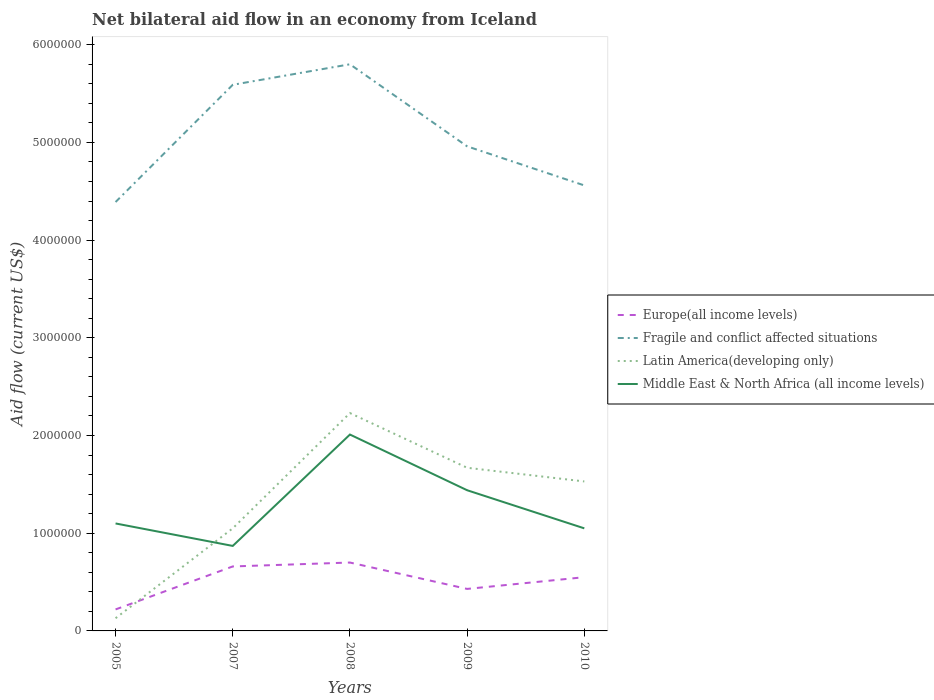What is the total net bilateral aid flow in Fragile and conflict affected situations in the graph?
Make the answer very short. 4.00e+05. What is the difference between the highest and the lowest net bilateral aid flow in Latin America(developing only)?
Ensure brevity in your answer.  3. Is the net bilateral aid flow in Fragile and conflict affected situations strictly greater than the net bilateral aid flow in Europe(all income levels) over the years?
Your answer should be compact. No. How many years are there in the graph?
Provide a succinct answer. 5. What is the difference between two consecutive major ticks on the Y-axis?
Provide a short and direct response. 1.00e+06. Are the values on the major ticks of Y-axis written in scientific E-notation?
Keep it short and to the point. No. Does the graph contain any zero values?
Give a very brief answer. No. Does the graph contain grids?
Your response must be concise. No. Where does the legend appear in the graph?
Your answer should be very brief. Center right. What is the title of the graph?
Make the answer very short. Net bilateral aid flow in an economy from Iceland. What is the Aid flow (current US$) of Europe(all income levels) in 2005?
Offer a terse response. 2.20e+05. What is the Aid flow (current US$) of Fragile and conflict affected situations in 2005?
Keep it short and to the point. 4.39e+06. What is the Aid flow (current US$) in Middle East & North Africa (all income levels) in 2005?
Give a very brief answer. 1.10e+06. What is the Aid flow (current US$) in Fragile and conflict affected situations in 2007?
Offer a terse response. 5.59e+06. What is the Aid flow (current US$) of Latin America(developing only) in 2007?
Offer a terse response. 1.05e+06. What is the Aid flow (current US$) of Middle East & North Africa (all income levels) in 2007?
Keep it short and to the point. 8.70e+05. What is the Aid flow (current US$) in Europe(all income levels) in 2008?
Give a very brief answer. 7.00e+05. What is the Aid flow (current US$) in Fragile and conflict affected situations in 2008?
Make the answer very short. 5.80e+06. What is the Aid flow (current US$) of Latin America(developing only) in 2008?
Offer a very short reply. 2.23e+06. What is the Aid flow (current US$) in Middle East & North Africa (all income levels) in 2008?
Offer a terse response. 2.01e+06. What is the Aid flow (current US$) of Fragile and conflict affected situations in 2009?
Your answer should be compact. 4.96e+06. What is the Aid flow (current US$) in Latin America(developing only) in 2009?
Your answer should be very brief. 1.67e+06. What is the Aid flow (current US$) of Middle East & North Africa (all income levels) in 2009?
Your response must be concise. 1.44e+06. What is the Aid flow (current US$) of Europe(all income levels) in 2010?
Ensure brevity in your answer.  5.50e+05. What is the Aid flow (current US$) in Fragile and conflict affected situations in 2010?
Offer a terse response. 4.56e+06. What is the Aid flow (current US$) in Latin America(developing only) in 2010?
Ensure brevity in your answer.  1.53e+06. What is the Aid flow (current US$) of Middle East & North Africa (all income levels) in 2010?
Provide a short and direct response. 1.05e+06. Across all years, what is the maximum Aid flow (current US$) of Europe(all income levels)?
Provide a short and direct response. 7.00e+05. Across all years, what is the maximum Aid flow (current US$) of Fragile and conflict affected situations?
Offer a terse response. 5.80e+06. Across all years, what is the maximum Aid flow (current US$) of Latin America(developing only)?
Ensure brevity in your answer.  2.23e+06. Across all years, what is the maximum Aid flow (current US$) in Middle East & North Africa (all income levels)?
Your answer should be compact. 2.01e+06. Across all years, what is the minimum Aid flow (current US$) of Fragile and conflict affected situations?
Provide a short and direct response. 4.39e+06. Across all years, what is the minimum Aid flow (current US$) in Latin America(developing only)?
Make the answer very short. 1.30e+05. Across all years, what is the minimum Aid flow (current US$) in Middle East & North Africa (all income levels)?
Your answer should be compact. 8.70e+05. What is the total Aid flow (current US$) in Europe(all income levels) in the graph?
Make the answer very short. 2.56e+06. What is the total Aid flow (current US$) of Fragile and conflict affected situations in the graph?
Your answer should be compact. 2.53e+07. What is the total Aid flow (current US$) in Latin America(developing only) in the graph?
Give a very brief answer. 6.61e+06. What is the total Aid flow (current US$) in Middle East & North Africa (all income levels) in the graph?
Offer a terse response. 6.47e+06. What is the difference between the Aid flow (current US$) in Europe(all income levels) in 2005 and that in 2007?
Offer a very short reply. -4.40e+05. What is the difference between the Aid flow (current US$) of Fragile and conflict affected situations in 2005 and that in 2007?
Your answer should be compact. -1.20e+06. What is the difference between the Aid flow (current US$) in Latin America(developing only) in 2005 and that in 2007?
Give a very brief answer. -9.20e+05. What is the difference between the Aid flow (current US$) of Middle East & North Africa (all income levels) in 2005 and that in 2007?
Offer a terse response. 2.30e+05. What is the difference between the Aid flow (current US$) of Europe(all income levels) in 2005 and that in 2008?
Your response must be concise. -4.80e+05. What is the difference between the Aid flow (current US$) in Fragile and conflict affected situations in 2005 and that in 2008?
Your response must be concise. -1.41e+06. What is the difference between the Aid flow (current US$) of Latin America(developing only) in 2005 and that in 2008?
Provide a short and direct response. -2.10e+06. What is the difference between the Aid flow (current US$) of Middle East & North Africa (all income levels) in 2005 and that in 2008?
Your response must be concise. -9.10e+05. What is the difference between the Aid flow (current US$) in Europe(all income levels) in 2005 and that in 2009?
Keep it short and to the point. -2.10e+05. What is the difference between the Aid flow (current US$) in Fragile and conflict affected situations in 2005 and that in 2009?
Make the answer very short. -5.70e+05. What is the difference between the Aid flow (current US$) in Latin America(developing only) in 2005 and that in 2009?
Your response must be concise. -1.54e+06. What is the difference between the Aid flow (current US$) of Middle East & North Africa (all income levels) in 2005 and that in 2009?
Offer a very short reply. -3.40e+05. What is the difference between the Aid flow (current US$) of Europe(all income levels) in 2005 and that in 2010?
Give a very brief answer. -3.30e+05. What is the difference between the Aid flow (current US$) of Fragile and conflict affected situations in 2005 and that in 2010?
Provide a succinct answer. -1.70e+05. What is the difference between the Aid flow (current US$) in Latin America(developing only) in 2005 and that in 2010?
Ensure brevity in your answer.  -1.40e+06. What is the difference between the Aid flow (current US$) of Fragile and conflict affected situations in 2007 and that in 2008?
Ensure brevity in your answer.  -2.10e+05. What is the difference between the Aid flow (current US$) in Latin America(developing only) in 2007 and that in 2008?
Your answer should be very brief. -1.18e+06. What is the difference between the Aid flow (current US$) in Middle East & North Africa (all income levels) in 2007 and that in 2008?
Your answer should be very brief. -1.14e+06. What is the difference between the Aid flow (current US$) of Fragile and conflict affected situations in 2007 and that in 2009?
Ensure brevity in your answer.  6.30e+05. What is the difference between the Aid flow (current US$) of Latin America(developing only) in 2007 and that in 2009?
Give a very brief answer. -6.20e+05. What is the difference between the Aid flow (current US$) in Middle East & North Africa (all income levels) in 2007 and that in 2009?
Provide a short and direct response. -5.70e+05. What is the difference between the Aid flow (current US$) of Fragile and conflict affected situations in 2007 and that in 2010?
Make the answer very short. 1.03e+06. What is the difference between the Aid flow (current US$) in Latin America(developing only) in 2007 and that in 2010?
Give a very brief answer. -4.80e+05. What is the difference between the Aid flow (current US$) in Europe(all income levels) in 2008 and that in 2009?
Ensure brevity in your answer.  2.70e+05. What is the difference between the Aid flow (current US$) in Fragile and conflict affected situations in 2008 and that in 2009?
Provide a succinct answer. 8.40e+05. What is the difference between the Aid flow (current US$) of Latin America(developing only) in 2008 and that in 2009?
Your answer should be compact. 5.60e+05. What is the difference between the Aid flow (current US$) in Middle East & North Africa (all income levels) in 2008 and that in 2009?
Provide a short and direct response. 5.70e+05. What is the difference between the Aid flow (current US$) of Europe(all income levels) in 2008 and that in 2010?
Provide a short and direct response. 1.50e+05. What is the difference between the Aid flow (current US$) of Fragile and conflict affected situations in 2008 and that in 2010?
Ensure brevity in your answer.  1.24e+06. What is the difference between the Aid flow (current US$) of Latin America(developing only) in 2008 and that in 2010?
Make the answer very short. 7.00e+05. What is the difference between the Aid flow (current US$) of Middle East & North Africa (all income levels) in 2008 and that in 2010?
Make the answer very short. 9.60e+05. What is the difference between the Aid flow (current US$) in Europe(all income levels) in 2009 and that in 2010?
Provide a succinct answer. -1.20e+05. What is the difference between the Aid flow (current US$) in Latin America(developing only) in 2009 and that in 2010?
Offer a terse response. 1.40e+05. What is the difference between the Aid flow (current US$) of Europe(all income levels) in 2005 and the Aid flow (current US$) of Fragile and conflict affected situations in 2007?
Your answer should be compact. -5.37e+06. What is the difference between the Aid flow (current US$) in Europe(all income levels) in 2005 and the Aid flow (current US$) in Latin America(developing only) in 2007?
Offer a terse response. -8.30e+05. What is the difference between the Aid flow (current US$) of Europe(all income levels) in 2005 and the Aid flow (current US$) of Middle East & North Africa (all income levels) in 2007?
Ensure brevity in your answer.  -6.50e+05. What is the difference between the Aid flow (current US$) in Fragile and conflict affected situations in 2005 and the Aid flow (current US$) in Latin America(developing only) in 2007?
Provide a succinct answer. 3.34e+06. What is the difference between the Aid flow (current US$) of Fragile and conflict affected situations in 2005 and the Aid flow (current US$) of Middle East & North Africa (all income levels) in 2007?
Make the answer very short. 3.52e+06. What is the difference between the Aid flow (current US$) in Latin America(developing only) in 2005 and the Aid flow (current US$) in Middle East & North Africa (all income levels) in 2007?
Provide a short and direct response. -7.40e+05. What is the difference between the Aid flow (current US$) in Europe(all income levels) in 2005 and the Aid flow (current US$) in Fragile and conflict affected situations in 2008?
Keep it short and to the point. -5.58e+06. What is the difference between the Aid flow (current US$) of Europe(all income levels) in 2005 and the Aid flow (current US$) of Latin America(developing only) in 2008?
Make the answer very short. -2.01e+06. What is the difference between the Aid flow (current US$) in Europe(all income levels) in 2005 and the Aid flow (current US$) in Middle East & North Africa (all income levels) in 2008?
Your answer should be compact. -1.79e+06. What is the difference between the Aid flow (current US$) of Fragile and conflict affected situations in 2005 and the Aid flow (current US$) of Latin America(developing only) in 2008?
Provide a succinct answer. 2.16e+06. What is the difference between the Aid flow (current US$) of Fragile and conflict affected situations in 2005 and the Aid flow (current US$) of Middle East & North Africa (all income levels) in 2008?
Your response must be concise. 2.38e+06. What is the difference between the Aid flow (current US$) of Latin America(developing only) in 2005 and the Aid flow (current US$) of Middle East & North Africa (all income levels) in 2008?
Your response must be concise. -1.88e+06. What is the difference between the Aid flow (current US$) in Europe(all income levels) in 2005 and the Aid flow (current US$) in Fragile and conflict affected situations in 2009?
Make the answer very short. -4.74e+06. What is the difference between the Aid flow (current US$) of Europe(all income levels) in 2005 and the Aid flow (current US$) of Latin America(developing only) in 2009?
Your response must be concise. -1.45e+06. What is the difference between the Aid flow (current US$) of Europe(all income levels) in 2005 and the Aid flow (current US$) of Middle East & North Africa (all income levels) in 2009?
Give a very brief answer. -1.22e+06. What is the difference between the Aid flow (current US$) in Fragile and conflict affected situations in 2005 and the Aid flow (current US$) in Latin America(developing only) in 2009?
Ensure brevity in your answer.  2.72e+06. What is the difference between the Aid flow (current US$) of Fragile and conflict affected situations in 2005 and the Aid flow (current US$) of Middle East & North Africa (all income levels) in 2009?
Offer a terse response. 2.95e+06. What is the difference between the Aid flow (current US$) of Latin America(developing only) in 2005 and the Aid flow (current US$) of Middle East & North Africa (all income levels) in 2009?
Offer a terse response. -1.31e+06. What is the difference between the Aid flow (current US$) of Europe(all income levels) in 2005 and the Aid flow (current US$) of Fragile and conflict affected situations in 2010?
Your answer should be very brief. -4.34e+06. What is the difference between the Aid flow (current US$) of Europe(all income levels) in 2005 and the Aid flow (current US$) of Latin America(developing only) in 2010?
Offer a terse response. -1.31e+06. What is the difference between the Aid flow (current US$) of Europe(all income levels) in 2005 and the Aid flow (current US$) of Middle East & North Africa (all income levels) in 2010?
Make the answer very short. -8.30e+05. What is the difference between the Aid flow (current US$) in Fragile and conflict affected situations in 2005 and the Aid flow (current US$) in Latin America(developing only) in 2010?
Make the answer very short. 2.86e+06. What is the difference between the Aid flow (current US$) of Fragile and conflict affected situations in 2005 and the Aid flow (current US$) of Middle East & North Africa (all income levels) in 2010?
Make the answer very short. 3.34e+06. What is the difference between the Aid flow (current US$) of Latin America(developing only) in 2005 and the Aid flow (current US$) of Middle East & North Africa (all income levels) in 2010?
Offer a very short reply. -9.20e+05. What is the difference between the Aid flow (current US$) of Europe(all income levels) in 2007 and the Aid flow (current US$) of Fragile and conflict affected situations in 2008?
Offer a very short reply. -5.14e+06. What is the difference between the Aid flow (current US$) in Europe(all income levels) in 2007 and the Aid flow (current US$) in Latin America(developing only) in 2008?
Give a very brief answer. -1.57e+06. What is the difference between the Aid flow (current US$) in Europe(all income levels) in 2007 and the Aid flow (current US$) in Middle East & North Africa (all income levels) in 2008?
Ensure brevity in your answer.  -1.35e+06. What is the difference between the Aid flow (current US$) in Fragile and conflict affected situations in 2007 and the Aid flow (current US$) in Latin America(developing only) in 2008?
Provide a short and direct response. 3.36e+06. What is the difference between the Aid flow (current US$) of Fragile and conflict affected situations in 2007 and the Aid flow (current US$) of Middle East & North Africa (all income levels) in 2008?
Give a very brief answer. 3.58e+06. What is the difference between the Aid flow (current US$) in Latin America(developing only) in 2007 and the Aid flow (current US$) in Middle East & North Africa (all income levels) in 2008?
Provide a short and direct response. -9.60e+05. What is the difference between the Aid flow (current US$) in Europe(all income levels) in 2007 and the Aid flow (current US$) in Fragile and conflict affected situations in 2009?
Offer a very short reply. -4.30e+06. What is the difference between the Aid flow (current US$) of Europe(all income levels) in 2007 and the Aid flow (current US$) of Latin America(developing only) in 2009?
Offer a very short reply. -1.01e+06. What is the difference between the Aid flow (current US$) in Europe(all income levels) in 2007 and the Aid flow (current US$) in Middle East & North Africa (all income levels) in 2009?
Provide a succinct answer. -7.80e+05. What is the difference between the Aid flow (current US$) of Fragile and conflict affected situations in 2007 and the Aid flow (current US$) of Latin America(developing only) in 2009?
Your response must be concise. 3.92e+06. What is the difference between the Aid flow (current US$) of Fragile and conflict affected situations in 2007 and the Aid flow (current US$) of Middle East & North Africa (all income levels) in 2009?
Provide a short and direct response. 4.15e+06. What is the difference between the Aid flow (current US$) of Latin America(developing only) in 2007 and the Aid flow (current US$) of Middle East & North Africa (all income levels) in 2009?
Offer a very short reply. -3.90e+05. What is the difference between the Aid flow (current US$) in Europe(all income levels) in 2007 and the Aid flow (current US$) in Fragile and conflict affected situations in 2010?
Provide a short and direct response. -3.90e+06. What is the difference between the Aid flow (current US$) in Europe(all income levels) in 2007 and the Aid flow (current US$) in Latin America(developing only) in 2010?
Provide a succinct answer. -8.70e+05. What is the difference between the Aid flow (current US$) of Europe(all income levels) in 2007 and the Aid flow (current US$) of Middle East & North Africa (all income levels) in 2010?
Make the answer very short. -3.90e+05. What is the difference between the Aid flow (current US$) of Fragile and conflict affected situations in 2007 and the Aid flow (current US$) of Latin America(developing only) in 2010?
Keep it short and to the point. 4.06e+06. What is the difference between the Aid flow (current US$) in Fragile and conflict affected situations in 2007 and the Aid flow (current US$) in Middle East & North Africa (all income levels) in 2010?
Offer a terse response. 4.54e+06. What is the difference between the Aid flow (current US$) in Latin America(developing only) in 2007 and the Aid flow (current US$) in Middle East & North Africa (all income levels) in 2010?
Ensure brevity in your answer.  0. What is the difference between the Aid flow (current US$) in Europe(all income levels) in 2008 and the Aid flow (current US$) in Fragile and conflict affected situations in 2009?
Your answer should be very brief. -4.26e+06. What is the difference between the Aid flow (current US$) of Europe(all income levels) in 2008 and the Aid flow (current US$) of Latin America(developing only) in 2009?
Provide a succinct answer. -9.70e+05. What is the difference between the Aid flow (current US$) of Europe(all income levels) in 2008 and the Aid flow (current US$) of Middle East & North Africa (all income levels) in 2009?
Ensure brevity in your answer.  -7.40e+05. What is the difference between the Aid flow (current US$) of Fragile and conflict affected situations in 2008 and the Aid flow (current US$) of Latin America(developing only) in 2009?
Provide a succinct answer. 4.13e+06. What is the difference between the Aid flow (current US$) of Fragile and conflict affected situations in 2008 and the Aid flow (current US$) of Middle East & North Africa (all income levels) in 2009?
Your answer should be very brief. 4.36e+06. What is the difference between the Aid flow (current US$) in Latin America(developing only) in 2008 and the Aid flow (current US$) in Middle East & North Africa (all income levels) in 2009?
Make the answer very short. 7.90e+05. What is the difference between the Aid flow (current US$) in Europe(all income levels) in 2008 and the Aid flow (current US$) in Fragile and conflict affected situations in 2010?
Keep it short and to the point. -3.86e+06. What is the difference between the Aid flow (current US$) in Europe(all income levels) in 2008 and the Aid flow (current US$) in Latin America(developing only) in 2010?
Provide a succinct answer. -8.30e+05. What is the difference between the Aid flow (current US$) in Europe(all income levels) in 2008 and the Aid flow (current US$) in Middle East & North Africa (all income levels) in 2010?
Offer a terse response. -3.50e+05. What is the difference between the Aid flow (current US$) in Fragile and conflict affected situations in 2008 and the Aid flow (current US$) in Latin America(developing only) in 2010?
Give a very brief answer. 4.27e+06. What is the difference between the Aid flow (current US$) in Fragile and conflict affected situations in 2008 and the Aid flow (current US$) in Middle East & North Africa (all income levels) in 2010?
Your answer should be very brief. 4.75e+06. What is the difference between the Aid flow (current US$) of Latin America(developing only) in 2008 and the Aid flow (current US$) of Middle East & North Africa (all income levels) in 2010?
Ensure brevity in your answer.  1.18e+06. What is the difference between the Aid flow (current US$) in Europe(all income levels) in 2009 and the Aid flow (current US$) in Fragile and conflict affected situations in 2010?
Keep it short and to the point. -4.13e+06. What is the difference between the Aid flow (current US$) of Europe(all income levels) in 2009 and the Aid flow (current US$) of Latin America(developing only) in 2010?
Keep it short and to the point. -1.10e+06. What is the difference between the Aid flow (current US$) in Europe(all income levels) in 2009 and the Aid flow (current US$) in Middle East & North Africa (all income levels) in 2010?
Your answer should be very brief. -6.20e+05. What is the difference between the Aid flow (current US$) in Fragile and conflict affected situations in 2009 and the Aid flow (current US$) in Latin America(developing only) in 2010?
Make the answer very short. 3.43e+06. What is the difference between the Aid flow (current US$) in Fragile and conflict affected situations in 2009 and the Aid flow (current US$) in Middle East & North Africa (all income levels) in 2010?
Offer a terse response. 3.91e+06. What is the difference between the Aid flow (current US$) of Latin America(developing only) in 2009 and the Aid flow (current US$) of Middle East & North Africa (all income levels) in 2010?
Give a very brief answer. 6.20e+05. What is the average Aid flow (current US$) of Europe(all income levels) per year?
Your answer should be very brief. 5.12e+05. What is the average Aid flow (current US$) in Fragile and conflict affected situations per year?
Your answer should be compact. 5.06e+06. What is the average Aid flow (current US$) in Latin America(developing only) per year?
Offer a very short reply. 1.32e+06. What is the average Aid flow (current US$) of Middle East & North Africa (all income levels) per year?
Your response must be concise. 1.29e+06. In the year 2005, what is the difference between the Aid flow (current US$) in Europe(all income levels) and Aid flow (current US$) in Fragile and conflict affected situations?
Your response must be concise. -4.17e+06. In the year 2005, what is the difference between the Aid flow (current US$) in Europe(all income levels) and Aid flow (current US$) in Middle East & North Africa (all income levels)?
Your response must be concise. -8.80e+05. In the year 2005, what is the difference between the Aid flow (current US$) of Fragile and conflict affected situations and Aid flow (current US$) of Latin America(developing only)?
Make the answer very short. 4.26e+06. In the year 2005, what is the difference between the Aid flow (current US$) of Fragile and conflict affected situations and Aid flow (current US$) of Middle East & North Africa (all income levels)?
Provide a succinct answer. 3.29e+06. In the year 2005, what is the difference between the Aid flow (current US$) of Latin America(developing only) and Aid flow (current US$) of Middle East & North Africa (all income levels)?
Provide a succinct answer. -9.70e+05. In the year 2007, what is the difference between the Aid flow (current US$) of Europe(all income levels) and Aid flow (current US$) of Fragile and conflict affected situations?
Offer a very short reply. -4.93e+06. In the year 2007, what is the difference between the Aid flow (current US$) in Europe(all income levels) and Aid flow (current US$) in Latin America(developing only)?
Your answer should be compact. -3.90e+05. In the year 2007, what is the difference between the Aid flow (current US$) in Europe(all income levels) and Aid flow (current US$) in Middle East & North Africa (all income levels)?
Your answer should be compact. -2.10e+05. In the year 2007, what is the difference between the Aid flow (current US$) of Fragile and conflict affected situations and Aid flow (current US$) of Latin America(developing only)?
Your response must be concise. 4.54e+06. In the year 2007, what is the difference between the Aid flow (current US$) of Fragile and conflict affected situations and Aid flow (current US$) of Middle East & North Africa (all income levels)?
Give a very brief answer. 4.72e+06. In the year 2007, what is the difference between the Aid flow (current US$) of Latin America(developing only) and Aid flow (current US$) of Middle East & North Africa (all income levels)?
Provide a short and direct response. 1.80e+05. In the year 2008, what is the difference between the Aid flow (current US$) in Europe(all income levels) and Aid flow (current US$) in Fragile and conflict affected situations?
Your answer should be compact. -5.10e+06. In the year 2008, what is the difference between the Aid flow (current US$) in Europe(all income levels) and Aid flow (current US$) in Latin America(developing only)?
Provide a succinct answer. -1.53e+06. In the year 2008, what is the difference between the Aid flow (current US$) of Europe(all income levels) and Aid flow (current US$) of Middle East & North Africa (all income levels)?
Make the answer very short. -1.31e+06. In the year 2008, what is the difference between the Aid flow (current US$) in Fragile and conflict affected situations and Aid flow (current US$) in Latin America(developing only)?
Your response must be concise. 3.57e+06. In the year 2008, what is the difference between the Aid flow (current US$) in Fragile and conflict affected situations and Aid flow (current US$) in Middle East & North Africa (all income levels)?
Provide a succinct answer. 3.79e+06. In the year 2009, what is the difference between the Aid flow (current US$) in Europe(all income levels) and Aid flow (current US$) in Fragile and conflict affected situations?
Your answer should be compact. -4.53e+06. In the year 2009, what is the difference between the Aid flow (current US$) of Europe(all income levels) and Aid flow (current US$) of Latin America(developing only)?
Your response must be concise. -1.24e+06. In the year 2009, what is the difference between the Aid flow (current US$) of Europe(all income levels) and Aid flow (current US$) of Middle East & North Africa (all income levels)?
Your response must be concise. -1.01e+06. In the year 2009, what is the difference between the Aid flow (current US$) of Fragile and conflict affected situations and Aid flow (current US$) of Latin America(developing only)?
Offer a terse response. 3.29e+06. In the year 2009, what is the difference between the Aid flow (current US$) of Fragile and conflict affected situations and Aid flow (current US$) of Middle East & North Africa (all income levels)?
Keep it short and to the point. 3.52e+06. In the year 2009, what is the difference between the Aid flow (current US$) in Latin America(developing only) and Aid flow (current US$) in Middle East & North Africa (all income levels)?
Ensure brevity in your answer.  2.30e+05. In the year 2010, what is the difference between the Aid flow (current US$) in Europe(all income levels) and Aid flow (current US$) in Fragile and conflict affected situations?
Your answer should be compact. -4.01e+06. In the year 2010, what is the difference between the Aid flow (current US$) in Europe(all income levels) and Aid flow (current US$) in Latin America(developing only)?
Offer a very short reply. -9.80e+05. In the year 2010, what is the difference between the Aid flow (current US$) of Europe(all income levels) and Aid flow (current US$) of Middle East & North Africa (all income levels)?
Your answer should be compact. -5.00e+05. In the year 2010, what is the difference between the Aid flow (current US$) in Fragile and conflict affected situations and Aid flow (current US$) in Latin America(developing only)?
Give a very brief answer. 3.03e+06. In the year 2010, what is the difference between the Aid flow (current US$) in Fragile and conflict affected situations and Aid flow (current US$) in Middle East & North Africa (all income levels)?
Provide a short and direct response. 3.51e+06. In the year 2010, what is the difference between the Aid flow (current US$) of Latin America(developing only) and Aid flow (current US$) of Middle East & North Africa (all income levels)?
Keep it short and to the point. 4.80e+05. What is the ratio of the Aid flow (current US$) in Fragile and conflict affected situations in 2005 to that in 2007?
Offer a terse response. 0.79. What is the ratio of the Aid flow (current US$) in Latin America(developing only) in 2005 to that in 2007?
Your answer should be compact. 0.12. What is the ratio of the Aid flow (current US$) in Middle East & North Africa (all income levels) in 2005 to that in 2007?
Your response must be concise. 1.26. What is the ratio of the Aid flow (current US$) in Europe(all income levels) in 2005 to that in 2008?
Your answer should be very brief. 0.31. What is the ratio of the Aid flow (current US$) in Fragile and conflict affected situations in 2005 to that in 2008?
Your answer should be very brief. 0.76. What is the ratio of the Aid flow (current US$) of Latin America(developing only) in 2005 to that in 2008?
Your answer should be compact. 0.06. What is the ratio of the Aid flow (current US$) of Middle East & North Africa (all income levels) in 2005 to that in 2008?
Give a very brief answer. 0.55. What is the ratio of the Aid flow (current US$) of Europe(all income levels) in 2005 to that in 2009?
Ensure brevity in your answer.  0.51. What is the ratio of the Aid flow (current US$) of Fragile and conflict affected situations in 2005 to that in 2009?
Your answer should be compact. 0.89. What is the ratio of the Aid flow (current US$) in Latin America(developing only) in 2005 to that in 2009?
Your answer should be compact. 0.08. What is the ratio of the Aid flow (current US$) of Middle East & North Africa (all income levels) in 2005 to that in 2009?
Offer a terse response. 0.76. What is the ratio of the Aid flow (current US$) in Fragile and conflict affected situations in 2005 to that in 2010?
Make the answer very short. 0.96. What is the ratio of the Aid flow (current US$) in Latin America(developing only) in 2005 to that in 2010?
Make the answer very short. 0.09. What is the ratio of the Aid flow (current US$) in Middle East & North Africa (all income levels) in 2005 to that in 2010?
Keep it short and to the point. 1.05. What is the ratio of the Aid flow (current US$) in Europe(all income levels) in 2007 to that in 2008?
Your answer should be compact. 0.94. What is the ratio of the Aid flow (current US$) in Fragile and conflict affected situations in 2007 to that in 2008?
Offer a very short reply. 0.96. What is the ratio of the Aid flow (current US$) in Latin America(developing only) in 2007 to that in 2008?
Provide a short and direct response. 0.47. What is the ratio of the Aid flow (current US$) of Middle East & North Africa (all income levels) in 2007 to that in 2008?
Give a very brief answer. 0.43. What is the ratio of the Aid flow (current US$) of Europe(all income levels) in 2007 to that in 2009?
Your answer should be very brief. 1.53. What is the ratio of the Aid flow (current US$) in Fragile and conflict affected situations in 2007 to that in 2009?
Your answer should be compact. 1.13. What is the ratio of the Aid flow (current US$) in Latin America(developing only) in 2007 to that in 2009?
Offer a terse response. 0.63. What is the ratio of the Aid flow (current US$) in Middle East & North Africa (all income levels) in 2007 to that in 2009?
Give a very brief answer. 0.6. What is the ratio of the Aid flow (current US$) of Europe(all income levels) in 2007 to that in 2010?
Make the answer very short. 1.2. What is the ratio of the Aid flow (current US$) in Fragile and conflict affected situations in 2007 to that in 2010?
Make the answer very short. 1.23. What is the ratio of the Aid flow (current US$) of Latin America(developing only) in 2007 to that in 2010?
Your response must be concise. 0.69. What is the ratio of the Aid flow (current US$) in Middle East & North Africa (all income levels) in 2007 to that in 2010?
Your response must be concise. 0.83. What is the ratio of the Aid flow (current US$) of Europe(all income levels) in 2008 to that in 2009?
Make the answer very short. 1.63. What is the ratio of the Aid flow (current US$) of Fragile and conflict affected situations in 2008 to that in 2009?
Ensure brevity in your answer.  1.17. What is the ratio of the Aid flow (current US$) in Latin America(developing only) in 2008 to that in 2009?
Your response must be concise. 1.34. What is the ratio of the Aid flow (current US$) in Middle East & North Africa (all income levels) in 2008 to that in 2009?
Your response must be concise. 1.4. What is the ratio of the Aid flow (current US$) in Europe(all income levels) in 2008 to that in 2010?
Provide a short and direct response. 1.27. What is the ratio of the Aid flow (current US$) in Fragile and conflict affected situations in 2008 to that in 2010?
Give a very brief answer. 1.27. What is the ratio of the Aid flow (current US$) of Latin America(developing only) in 2008 to that in 2010?
Give a very brief answer. 1.46. What is the ratio of the Aid flow (current US$) in Middle East & North Africa (all income levels) in 2008 to that in 2010?
Give a very brief answer. 1.91. What is the ratio of the Aid flow (current US$) of Europe(all income levels) in 2009 to that in 2010?
Your response must be concise. 0.78. What is the ratio of the Aid flow (current US$) of Fragile and conflict affected situations in 2009 to that in 2010?
Your answer should be compact. 1.09. What is the ratio of the Aid flow (current US$) in Latin America(developing only) in 2009 to that in 2010?
Give a very brief answer. 1.09. What is the ratio of the Aid flow (current US$) of Middle East & North Africa (all income levels) in 2009 to that in 2010?
Give a very brief answer. 1.37. What is the difference between the highest and the second highest Aid flow (current US$) in Europe(all income levels)?
Your answer should be very brief. 4.00e+04. What is the difference between the highest and the second highest Aid flow (current US$) in Fragile and conflict affected situations?
Ensure brevity in your answer.  2.10e+05. What is the difference between the highest and the second highest Aid flow (current US$) of Latin America(developing only)?
Give a very brief answer. 5.60e+05. What is the difference between the highest and the second highest Aid flow (current US$) in Middle East & North Africa (all income levels)?
Provide a short and direct response. 5.70e+05. What is the difference between the highest and the lowest Aid flow (current US$) of Europe(all income levels)?
Offer a terse response. 4.80e+05. What is the difference between the highest and the lowest Aid flow (current US$) in Fragile and conflict affected situations?
Offer a very short reply. 1.41e+06. What is the difference between the highest and the lowest Aid flow (current US$) in Latin America(developing only)?
Give a very brief answer. 2.10e+06. What is the difference between the highest and the lowest Aid flow (current US$) in Middle East & North Africa (all income levels)?
Keep it short and to the point. 1.14e+06. 